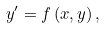<formula> <loc_0><loc_0><loc_500><loc_500>y ^ { \prime } = f \left ( x , y \right ) ,</formula> 